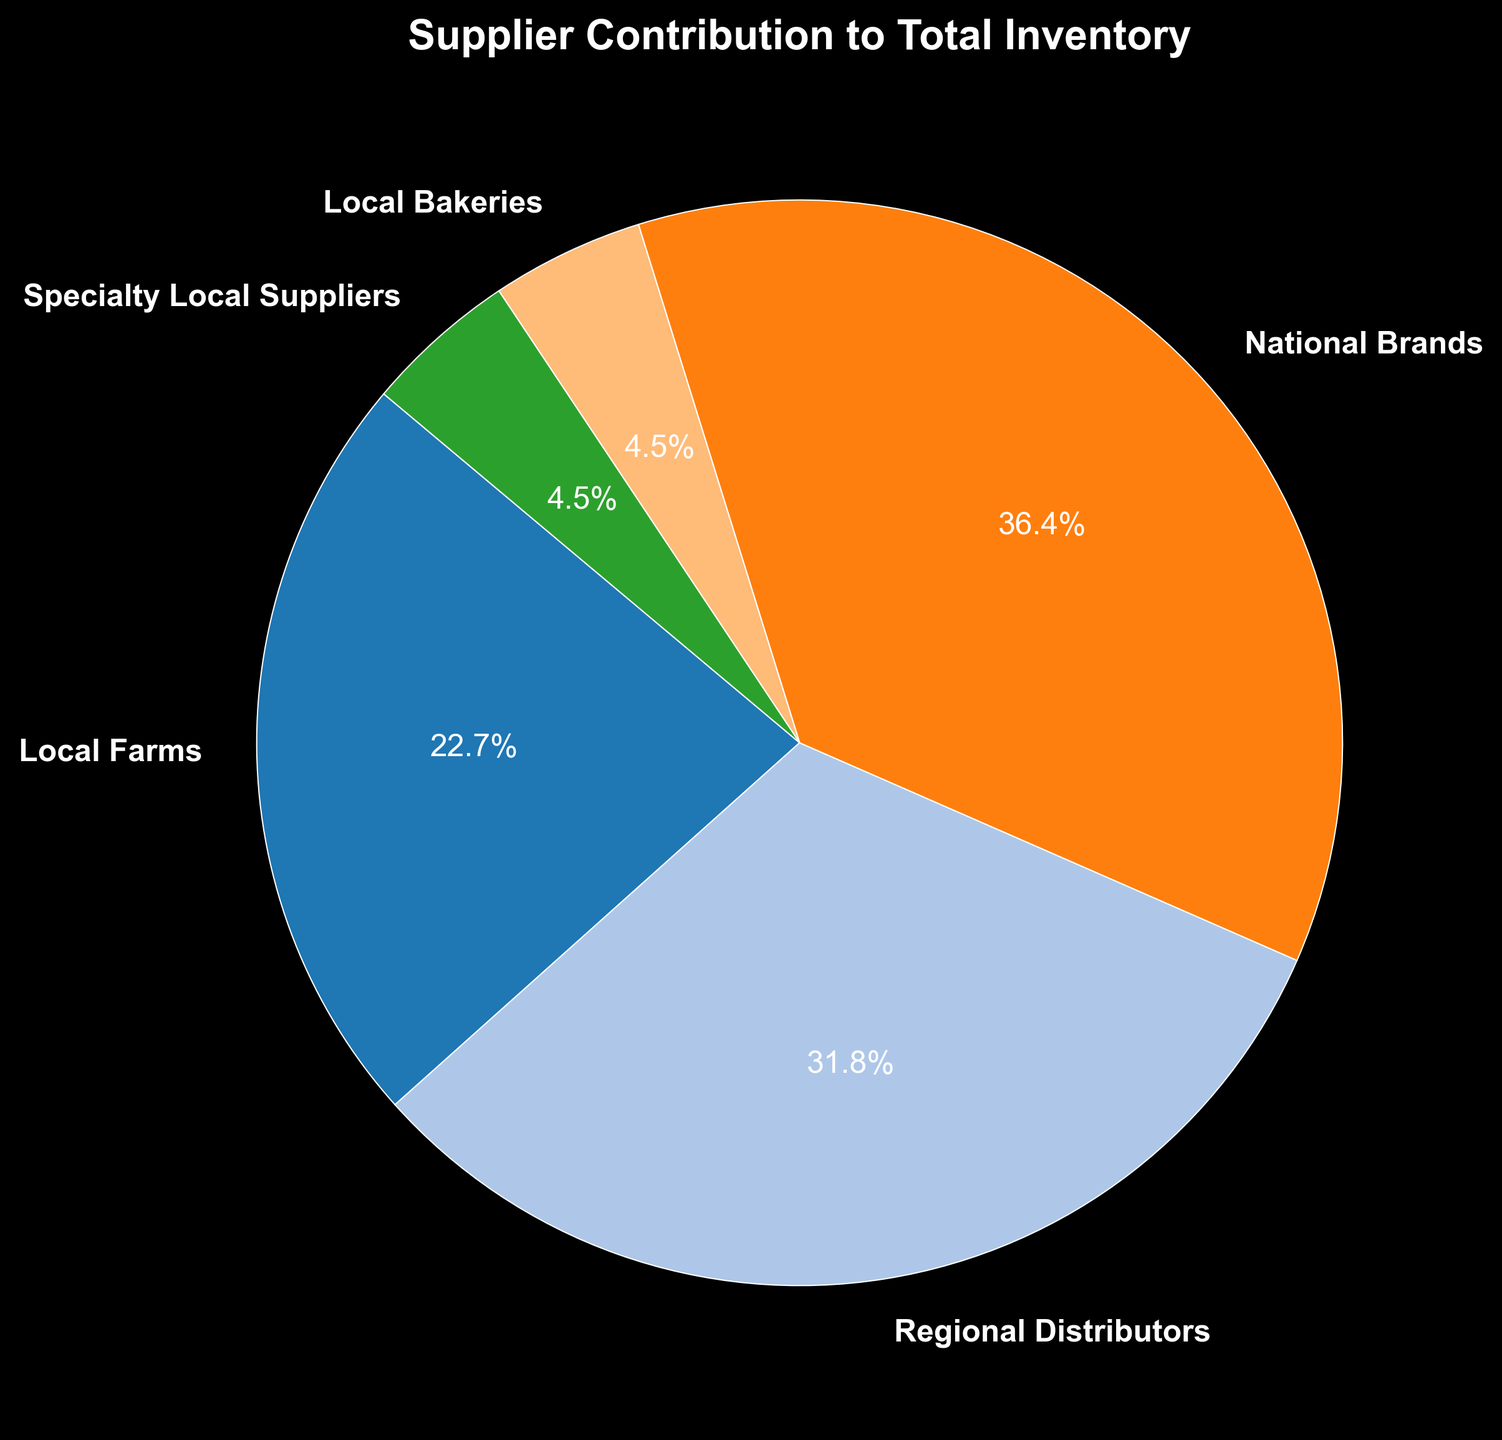What's the total contribution of local suppliers (Local Farms, Local Bakeries, Specialty Local Suppliers)? To find the total contribution of local suppliers, sum their contributions: Local Farms (25%) + Local Bakeries (5%) + Specialty Local Suppliers (5%). So, 25% + 5% + 5% = 35%.
Answer: 35% Which supplier contributes the most to the total inventory? Observe the pie chart. National Brands has the largest section, indicating the highest contribution of 40%.
Answer: National Brands Is the contribution from Regional Distributors greater than that from Local Farms? Compare the percentages in the pie chart for Regional Distributors (35%) and Local Farms (25%). 35% > 25%.
Answer: Yes What is the difference in contribution between the largest and smallest supplier groups? The largest contribution is from National Brands (40%), and the smallest contributions are from Local Bakeries and Specialty Local Suppliers (both 5%). The difference is 40% - 5% = 35%.
Answer: 35% Which color represents Local Farms, and what is its contribution? Locate Local Farms in the pie chart and note its color and contribution. Suppose Local Farms is represented in orange (this is a hypothetical color as we can't see the chart). Its contribution is 25%.
Answer: Orange, 25% If you combine the contributions of Local Farms and National Brands, what percentage of the total inventory do they comprise? Add Local Farms' contribution (25%) and National Brands' contribution (40%). So, 25% + 40% = 65%.
Answer: 65% Are the combined contributions of Local Bakeries and Specialty Local Suppliers less than the contribution of Local Farms? Both Local Bakeries and Specialty Local Suppliers each contribute 5%. Their combined contribution is 5% + 5% = 10%. Local Farms contributes 25%. 10% < 25%.
Answer: Yes Which supplier's contribution is exactly equal to the sum of Local Bakeries and Specialty Local Suppliers? The sum of contributions from Local Bakeries and Specialty Local Suppliers is 5% + 5% = 10%. Compare this to other suppliers' contributions in the chart. None match exactly, so the answer is none.
Answer: None What percentage more does National Brands contribute compared to Local Farms? Subtract Local Farms' contribution (25%) from National Brands' contribution (40%). Calculate the difference: 40% - 25% = 15%.
Answer: 15% Name the suppliers that contribute less than 10% each to the total inventory. Identify each supplier's contribution on the pie chart. Local Bakeries (5%) and Specialty Local Suppliers (5%) each contribute less than 10%.
Answer: Local Bakeries, Specialty Local Suppliers 